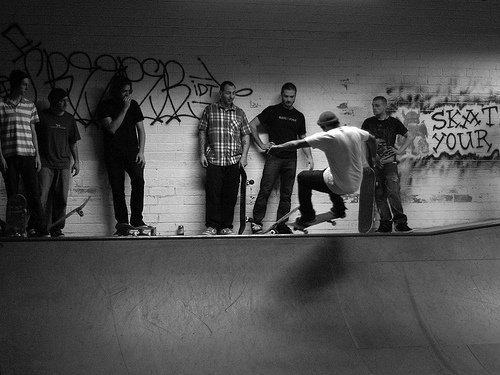<image>What does the wall say on the far left? I don't know. The answers are quite ambiguous. It may say 'idt', 'pb9999b', 'skat your', 'pb998bidt', or it may be just some graffiti. What does the wall say on the far left? I don't know what the wall says on the far left. It can be seen 'idt', 'pb9999b', 'skat your', 'pb998bidt' or 'nothing its graffiti'. 